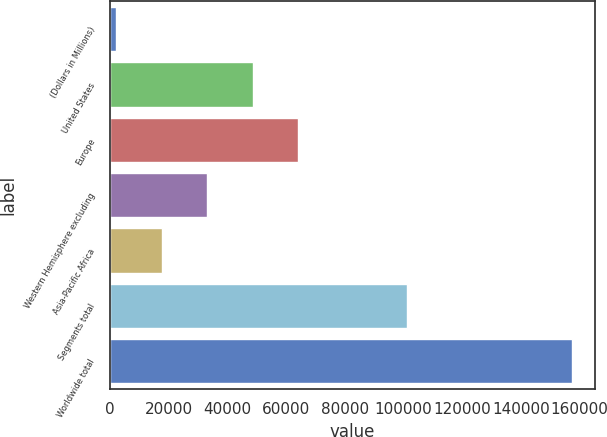Convert chart to OTSL. <chart><loc_0><loc_0><loc_500><loc_500><bar_chart><fcel>(Dollars in Millions)<fcel>United States<fcel>Europe<fcel>Western Hemisphere excluding<fcel>Asia-Pacific Africa<fcel>Segments total<fcel>Worldwide total<nl><fcel>2017<fcel>48602.8<fcel>64131.4<fcel>33074.2<fcel>17545.6<fcel>100996<fcel>157303<nl></chart> 